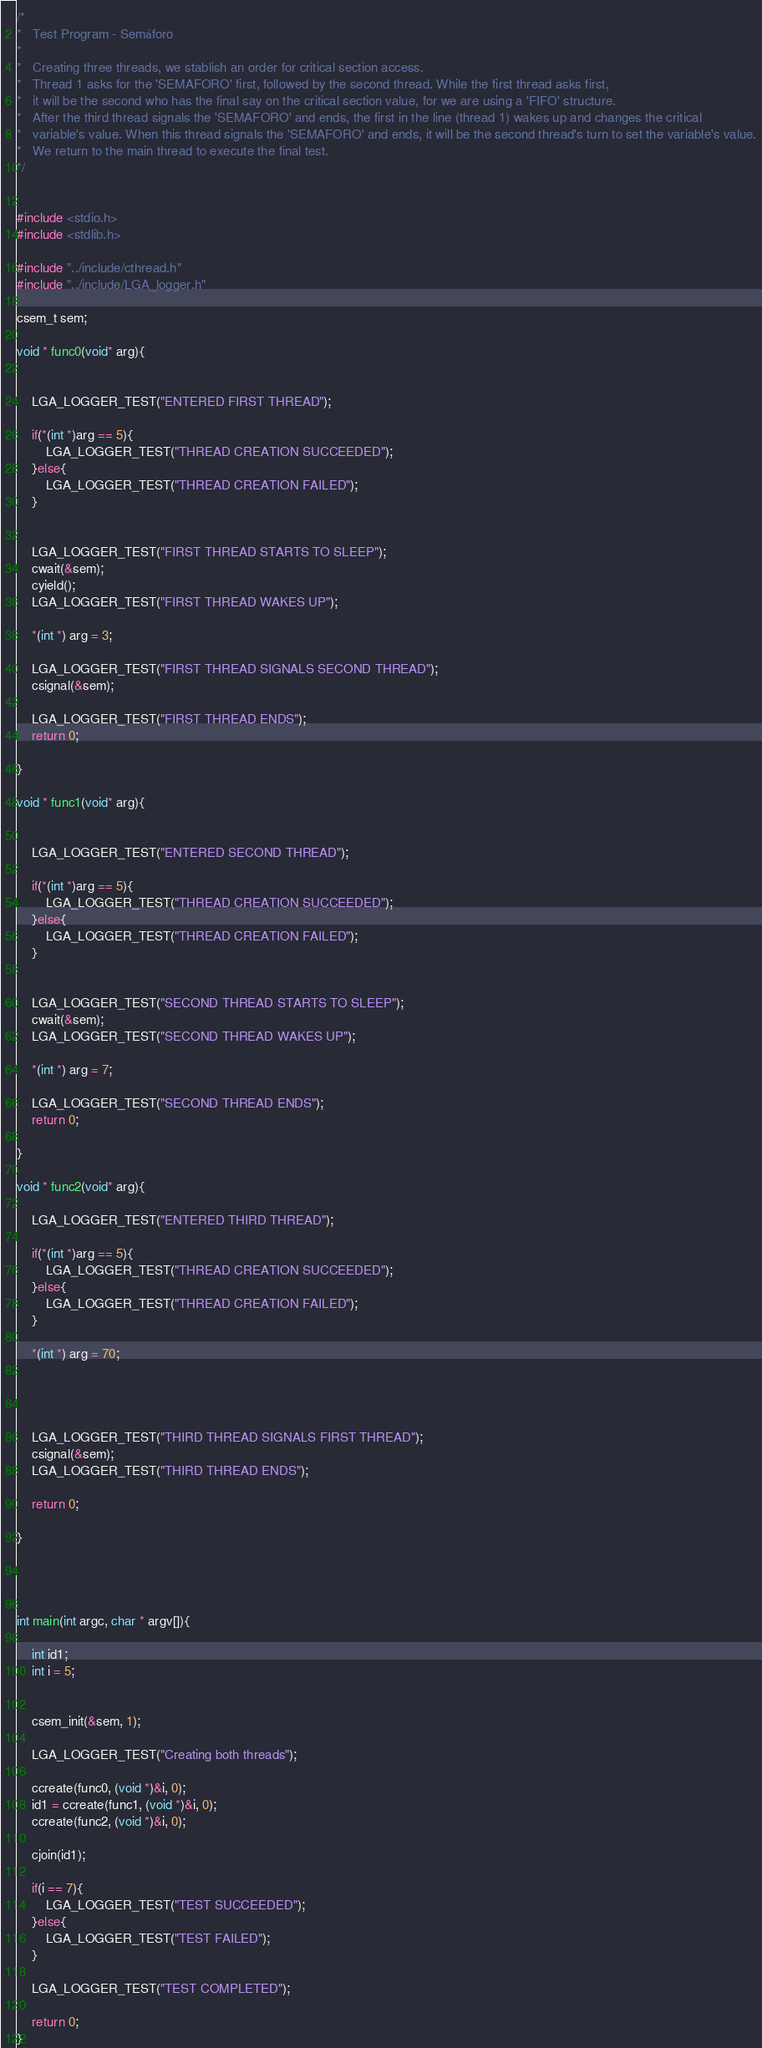<code> <loc_0><loc_0><loc_500><loc_500><_C_>/*
*   Test Program - Semáforo
*
*   Creating three threads, we stablish an order for critical section access.
*   Thread 1 asks for the 'SEMAFORO' first, followed by the second thread. While the first thread asks first, 
*   it will be the second who has the final say on the critical section value, for we are using a 'FIFO' structure.
*   After the third thread signals the 'SEMAFORO' and ends, the first in the line (thread 1) wakes up and changes the critical
*   variable's value. When this thread signals the 'SEMAFORO' and ends, it will be the second thread's turn to set the variable's value.
*   We return to the main thread to execute the final test. 
*/


#include <stdio.h>
#include <stdlib.h>

#include "../include/cthread.h"
#include "../include/LGA_logger.h"

csem_t sem;

void * func0(void* arg){


    LGA_LOGGER_TEST("ENTERED FIRST THREAD");

    if(*(int *)arg == 5){
        LGA_LOGGER_TEST("THREAD CREATION SUCCEEDED");
    }else{
        LGA_LOGGER_TEST("THREAD CREATION FAILED");
    }
    

    LGA_LOGGER_TEST("FIRST THREAD STARTS TO SLEEP");
    cwait(&sem);
    cyield();
    LGA_LOGGER_TEST("FIRST THREAD WAKES UP");

    *(int *) arg = 3;

    LGA_LOGGER_TEST("FIRST THREAD SIGNALS SECOND THREAD");
    csignal(&sem);

    LGA_LOGGER_TEST("FIRST THREAD ENDS");
    return 0;

}

void * func1(void* arg){


    LGA_LOGGER_TEST("ENTERED SECOND THREAD");

    if(*(int *)arg == 5){
        LGA_LOGGER_TEST("THREAD CREATION SUCCEEDED");
    }else{
        LGA_LOGGER_TEST("THREAD CREATION FAILED");
    }
    

    LGA_LOGGER_TEST("SECOND THREAD STARTS TO SLEEP");
    cwait(&sem);
    LGA_LOGGER_TEST("SECOND THREAD WAKES UP");

    *(int *) arg = 7;

    LGA_LOGGER_TEST("SECOND THREAD ENDS");
    return 0;

}

void * func2(void* arg){

    LGA_LOGGER_TEST("ENTERED THIRD THREAD");

    if(*(int *)arg == 5){
        LGA_LOGGER_TEST("THREAD CREATION SUCCEEDED");
    }else{
        LGA_LOGGER_TEST("THREAD CREATION FAILED");
    }
    
    *(int *) arg = 70;




    LGA_LOGGER_TEST("THIRD THREAD SIGNALS FIRST THREAD");
    csignal(&sem);
    LGA_LOGGER_TEST("THIRD THREAD ENDS");

    return 0;

}




int main(int argc, char * argv[]){

    int id1;
    int i = 5;


    csem_init(&sem, 1);

    LGA_LOGGER_TEST("Creating both threads");

    ccreate(func0, (void *)&i, 0);
    id1 = ccreate(func1, (void *)&i, 0);
    ccreate(func2, (void *)&i, 0);

    cjoin(id1);

    if(i == 7){        
        LGA_LOGGER_TEST("TEST SUCCEEDED");
    }else{
        LGA_LOGGER_TEST("TEST FAILED");
    }

    LGA_LOGGER_TEST("TEST COMPLETED");

    return 0;
}</code> 